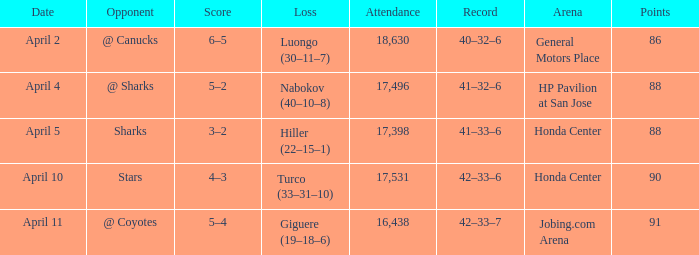Which score possesses a loss of hiller (22–15–1)? 3–2. 